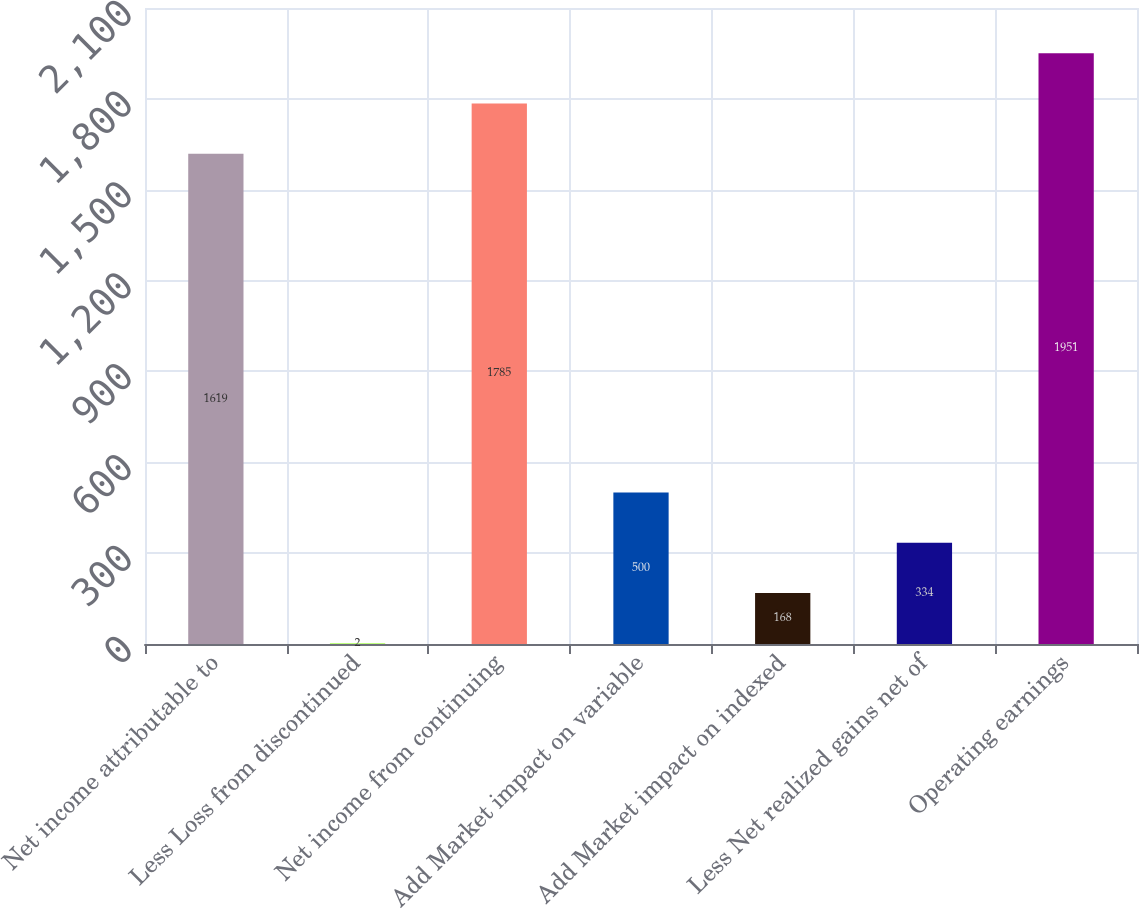<chart> <loc_0><loc_0><loc_500><loc_500><bar_chart><fcel>Net income attributable to<fcel>Less Loss from discontinued<fcel>Net income from continuing<fcel>Add Market impact on variable<fcel>Add Market impact on indexed<fcel>Less Net realized gains net of<fcel>Operating earnings<nl><fcel>1619<fcel>2<fcel>1785<fcel>500<fcel>168<fcel>334<fcel>1951<nl></chart> 